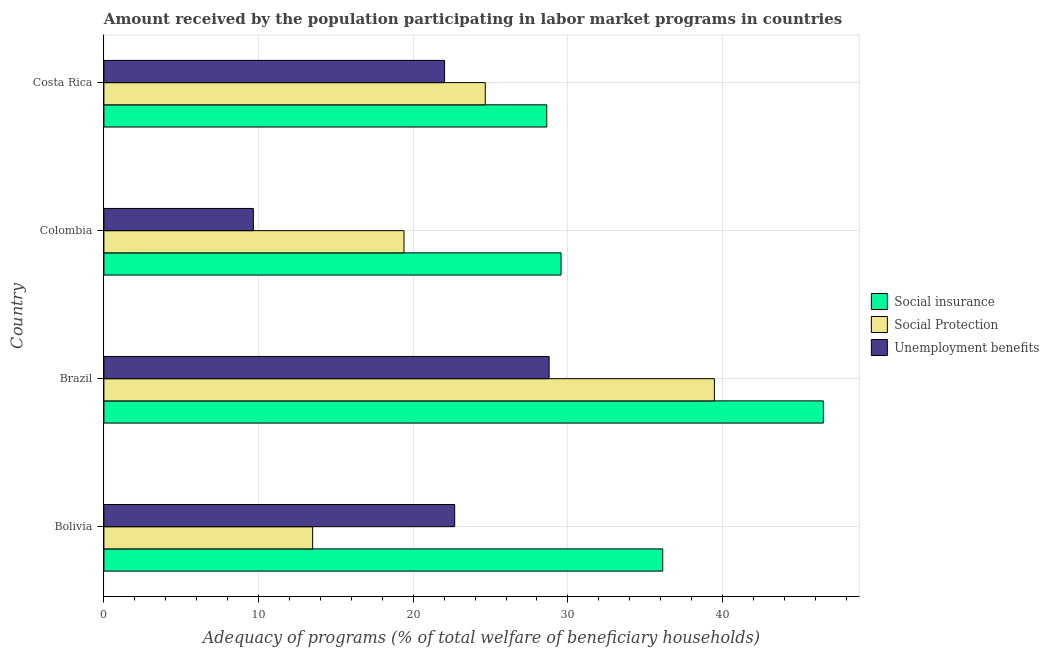Are the number of bars on each tick of the Y-axis equal?
Ensure brevity in your answer.  Yes. How many bars are there on the 1st tick from the top?
Make the answer very short. 3. How many bars are there on the 4th tick from the bottom?
Keep it short and to the point. 3. In how many cases, is the number of bars for a given country not equal to the number of legend labels?
Provide a succinct answer. 0. What is the amount received by the population participating in social insurance programs in Brazil?
Ensure brevity in your answer.  46.52. Across all countries, what is the maximum amount received by the population participating in social insurance programs?
Offer a terse response. 46.52. Across all countries, what is the minimum amount received by the population participating in unemployment benefits programs?
Provide a short and direct response. 9.66. What is the total amount received by the population participating in social protection programs in the graph?
Give a very brief answer. 97.03. What is the difference between the amount received by the population participating in social protection programs in Bolivia and that in Colombia?
Provide a succinct answer. -5.91. What is the difference between the amount received by the population participating in unemployment benefits programs in Colombia and the amount received by the population participating in social protection programs in Bolivia?
Keep it short and to the point. -3.83. What is the average amount received by the population participating in social protection programs per country?
Offer a very short reply. 24.26. What is the difference between the amount received by the population participating in unemployment benefits programs and amount received by the population participating in social protection programs in Colombia?
Offer a very short reply. -9.74. In how many countries, is the amount received by the population participating in social insurance programs greater than 8 %?
Your response must be concise. 4. What is the ratio of the amount received by the population participating in unemployment benefits programs in Brazil to that in Costa Rica?
Your response must be concise. 1.31. What is the difference between the highest and the second highest amount received by the population participating in social protection programs?
Provide a short and direct response. 14.81. What is the difference between the highest and the lowest amount received by the population participating in social protection programs?
Your answer should be compact. 25.98. Is the sum of the amount received by the population participating in social insurance programs in Bolivia and Costa Rica greater than the maximum amount received by the population participating in social protection programs across all countries?
Ensure brevity in your answer.  Yes. What does the 2nd bar from the top in Bolivia represents?
Make the answer very short. Social Protection. What does the 1st bar from the bottom in Bolivia represents?
Make the answer very short. Social insurance. Is it the case that in every country, the sum of the amount received by the population participating in social insurance programs and amount received by the population participating in social protection programs is greater than the amount received by the population participating in unemployment benefits programs?
Keep it short and to the point. Yes. How many bars are there?
Your answer should be compact. 12. How many countries are there in the graph?
Provide a short and direct response. 4. Are the values on the major ticks of X-axis written in scientific E-notation?
Your answer should be very brief. No. Does the graph contain any zero values?
Your response must be concise. No. Does the graph contain grids?
Provide a succinct answer. Yes. Where does the legend appear in the graph?
Provide a succinct answer. Center right. How many legend labels are there?
Offer a very short reply. 3. What is the title of the graph?
Your response must be concise. Amount received by the population participating in labor market programs in countries. Does "Ores and metals" appear as one of the legend labels in the graph?
Your answer should be very brief. No. What is the label or title of the X-axis?
Ensure brevity in your answer.  Adequacy of programs (% of total welfare of beneficiary households). What is the Adequacy of programs (% of total welfare of beneficiary households) in Social insurance in Bolivia?
Your answer should be compact. 36.13. What is the Adequacy of programs (% of total welfare of beneficiary households) of Social Protection in Bolivia?
Make the answer very short. 13.5. What is the Adequacy of programs (% of total welfare of beneficiary households) of Unemployment benefits in Bolivia?
Keep it short and to the point. 22.68. What is the Adequacy of programs (% of total welfare of beneficiary households) in Social insurance in Brazil?
Your answer should be compact. 46.52. What is the Adequacy of programs (% of total welfare of beneficiary households) in Social Protection in Brazil?
Offer a terse response. 39.47. What is the Adequacy of programs (% of total welfare of beneficiary households) in Unemployment benefits in Brazil?
Your answer should be very brief. 28.79. What is the Adequacy of programs (% of total welfare of beneficiary households) in Social insurance in Colombia?
Provide a short and direct response. 29.56. What is the Adequacy of programs (% of total welfare of beneficiary households) of Social Protection in Colombia?
Your response must be concise. 19.4. What is the Adequacy of programs (% of total welfare of beneficiary households) of Unemployment benefits in Colombia?
Your answer should be very brief. 9.66. What is the Adequacy of programs (% of total welfare of beneficiary households) of Social insurance in Costa Rica?
Offer a very short reply. 28.64. What is the Adequacy of programs (% of total welfare of beneficiary households) of Social Protection in Costa Rica?
Offer a very short reply. 24.66. What is the Adequacy of programs (% of total welfare of beneficiary households) in Unemployment benefits in Costa Rica?
Your answer should be compact. 22.03. Across all countries, what is the maximum Adequacy of programs (% of total welfare of beneficiary households) in Social insurance?
Keep it short and to the point. 46.52. Across all countries, what is the maximum Adequacy of programs (% of total welfare of beneficiary households) of Social Protection?
Your answer should be very brief. 39.47. Across all countries, what is the maximum Adequacy of programs (% of total welfare of beneficiary households) of Unemployment benefits?
Ensure brevity in your answer.  28.79. Across all countries, what is the minimum Adequacy of programs (% of total welfare of beneficiary households) of Social insurance?
Your answer should be compact. 28.64. Across all countries, what is the minimum Adequacy of programs (% of total welfare of beneficiary households) of Social Protection?
Your answer should be very brief. 13.5. Across all countries, what is the minimum Adequacy of programs (% of total welfare of beneficiary households) in Unemployment benefits?
Provide a short and direct response. 9.66. What is the total Adequacy of programs (% of total welfare of beneficiary households) of Social insurance in the graph?
Offer a very short reply. 140.85. What is the total Adequacy of programs (% of total welfare of beneficiary households) in Social Protection in the graph?
Provide a succinct answer. 97.03. What is the total Adequacy of programs (% of total welfare of beneficiary households) in Unemployment benefits in the graph?
Provide a succinct answer. 83.16. What is the difference between the Adequacy of programs (% of total welfare of beneficiary households) in Social insurance in Bolivia and that in Brazil?
Ensure brevity in your answer.  -10.39. What is the difference between the Adequacy of programs (% of total welfare of beneficiary households) in Social Protection in Bolivia and that in Brazil?
Offer a very short reply. -25.98. What is the difference between the Adequacy of programs (% of total welfare of beneficiary households) of Unemployment benefits in Bolivia and that in Brazil?
Offer a very short reply. -6.11. What is the difference between the Adequacy of programs (% of total welfare of beneficiary households) of Social insurance in Bolivia and that in Colombia?
Offer a terse response. 6.57. What is the difference between the Adequacy of programs (% of total welfare of beneficiary households) in Social Protection in Bolivia and that in Colombia?
Provide a succinct answer. -5.9. What is the difference between the Adequacy of programs (% of total welfare of beneficiary households) in Unemployment benefits in Bolivia and that in Colombia?
Give a very brief answer. 13.02. What is the difference between the Adequacy of programs (% of total welfare of beneficiary households) in Social insurance in Bolivia and that in Costa Rica?
Make the answer very short. 7.5. What is the difference between the Adequacy of programs (% of total welfare of beneficiary households) of Social Protection in Bolivia and that in Costa Rica?
Keep it short and to the point. -11.16. What is the difference between the Adequacy of programs (% of total welfare of beneficiary households) in Unemployment benefits in Bolivia and that in Costa Rica?
Offer a very short reply. 0.65. What is the difference between the Adequacy of programs (% of total welfare of beneficiary households) of Social insurance in Brazil and that in Colombia?
Make the answer very short. 16.96. What is the difference between the Adequacy of programs (% of total welfare of beneficiary households) of Social Protection in Brazil and that in Colombia?
Provide a succinct answer. 20.07. What is the difference between the Adequacy of programs (% of total welfare of beneficiary households) of Unemployment benefits in Brazil and that in Colombia?
Provide a succinct answer. 19.12. What is the difference between the Adequacy of programs (% of total welfare of beneficiary households) in Social insurance in Brazil and that in Costa Rica?
Offer a terse response. 17.89. What is the difference between the Adequacy of programs (% of total welfare of beneficiary households) of Social Protection in Brazil and that in Costa Rica?
Offer a terse response. 14.81. What is the difference between the Adequacy of programs (% of total welfare of beneficiary households) of Unemployment benefits in Brazil and that in Costa Rica?
Provide a succinct answer. 6.76. What is the difference between the Adequacy of programs (% of total welfare of beneficiary households) of Social Protection in Colombia and that in Costa Rica?
Ensure brevity in your answer.  -5.26. What is the difference between the Adequacy of programs (% of total welfare of beneficiary households) of Unemployment benefits in Colombia and that in Costa Rica?
Your answer should be compact. -12.37. What is the difference between the Adequacy of programs (% of total welfare of beneficiary households) in Social insurance in Bolivia and the Adequacy of programs (% of total welfare of beneficiary households) in Social Protection in Brazil?
Make the answer very short. -3.34. What is the difference between the Adequacy of programs (% of total welfare of beneficiary households) in Social insurance in Bolivia and the Adequacy of programs (% of total welfare of beneficiary households) in Unemployment benefits in Brazil?
Your response must be concise. 7.35. What is the difference between the Adequacy of programs (% of total welfare of beneficiary households) of Social Protection in Bolivia and the Adequacy of programs (% of total welfare of beneficiary households) of Unemployment benefits in Brazil?
Provide a succinct answer. -15.29. What is the difference between the Adequacy of programs (% of total welfare of beneficiary households) in Social insurance in Bolivia and the Adequacy of programs (% of total welfare of beneficiary households) in Social Protection in Colombia?
Give a very brief answer. 16.73. What is the difference between the Adequacy of programs (% of total welfare of beneficiary households) in Social insurance in Bolivia and the Adequacy of programs (% of total welfare of beneficiary households) in Unemployment benefits in Colombia?
Offer a terse response. 26.47. What is the difference between the Adequacy of programs (% of total welfare of beneficiary households) of Social Protection in Bolivia and the Adequacy of programs (% of total welfare of beneficiary households) of Unemployment benefits in Colombia?
Provide a succinct answer. 3.83. What is the difference between the Adequacy of programs (% of total welfare of beneficiary households) of Social insurance in Bolivia and the Adequacy of programs (% of total welfare of beneficiary households) of Social Protection in Costa Rica?
Provide a short and direct response. 11.47. What is the difference between the Adequacy of programs (% of total welfare of beneficiary households) in Social insurance in Bolivia and the Adequacy of programs (% of total welfare of beneficiary households) in Unemployment benefits in Costa Rica?
Offer a very short reply. 14.1. What is the difference between the Adequacy of programs (% of total welfare of beneficiary households) in Social Protection in Bolivia and the Adequacy of programs (% of total welfare of beneficiary households) in Unemployment benefits in Costa Rica?
Your answer should be compact. -8.53. What is the difference between the Adequacy of programs (% of total welfare of beneficiary households) in Social insurance in Brazil and the Adequacy of programs (% of total welfare of beneficiary households) in Social Protection in Colombia?
Offer a very short reply. 27.12. What is the difference between the Adequacy of programs (% of total welfare of beneficiary households) of Social insurance in Brazil and the Adequacy of programs (% of total welfare of beneficiary households) of Unemployment benefits in Colombia?
Your response must be concise. 36.86. What is the difference between the Adequacy of programs (% of total welfare of beneficiary households) of Social Protection in Brazil and the Adequacy of programs (% of total welfare of beneficiary households) of Unemployment benefits in Colombia?
Offer a very short reply. 29.81. What is the difference between the Adequacy of programs (% of total welfare of beneficiary households) of Social insurance in Brazil and the Adequacy of programs (% of total welfare of beneficiary households) of Social Protection in Costa Rica?
Provide a succinct answer. 21.86. What is the difference between the Adequacy of programs (% of total welfare of beneficiary households) in Social insurance in Brazil and the Adequacy of programs (% of total welfare of beneficiary households) in Unemployment benefits in Costa Rica?
Provide a short and direct response. 24.49. What is the difference between the Adequacy of programs (% of total welfare of beneficiary households) of Social Protection in Brazil and the Adequacy of programs (% of total welfare of beneficiary households) of Unemployment benefits in Costa Rica?
Your answer should be compact. 17.44. What is the difference between the Adequacy of programs (% of total welfare of beneficiary households) in Social insurance in Colombia and the Adequacy of programs (% of total welfare of beneficiary households) in Social Protection in Costa Rica?
Make the answer very short. 4.9. What is the difference between the Adequacy of programs (% of total welfare of beneficiary households) of Social insurance in Colombia and the Adequacy of programs (% of total welfare of beneficiary households) of Unemployment benefits in Costa Rica?
Your answer should be compact. 7.53. What is the difference between the Adequacy of programs (% of total welfare of beneficiary households) in Social Protection in Colombia and the Adequacy of programs (% of total welfare of beneficiary households) in Unemployment benefits in Costa Rica?
Provide a succinct answer. -2.63. What is the average Adequacy of programs (% of total welfare of beneficiary households) in Social insurance per country?
Provide a short and direct response. 35.21. What is the average Adequacy of programs (% of total welfare of beneficiary households) of Social Protection per country?
Your response must be concise. 24.26. What is the average Adequacy of programs (% of total welfare of beneficiary households) in Unemployment benefits per country?
Your answer should be very brief. 20.79. What is the difference between the Adequacy of programs (% of total welfare of beneficiary households) in Social insurance and Adequacy of programs (% of total welfare of beneficiary households) in Social Protection in Bolivia?
Ensure brevity in your answer.  22.64. What is the difference between the Adequacy of programs (% of total welfare of beneficiary households) of Social insurance and Adequacy of programs (% of total welfare of beneficiary households) of Unemployment benefits in Bolivia?
Provide a short and direct response. 13.45. What is the difference between the Adequacy of programs (% of total welfare of beneficiary households) in Social Protection and Adequacy of programs (% of total welfare of beneficiary households) in Unemployment benefits in Bolivia?
Provide a succinct answer. -9.19. What is the difference between the Adequacy of programs (% of total welfare of beneficiary households) of Social insurance and Adequacy of programs (% of total welfare of beneficiary households) of Social Protection in Brazil?
Provide a succinct answer. 7.05. What is the difference between the Adequacy of programs (% of total welfare of beneficiary households) in Social insurance and Adequacy of programs (% of total welfare of beneficiary households) in Unemployment benefits in Brazil?
Keep it short and to the point. 17.73. What is the difference between the Adequacy of programs (% of total welfare of beneficiary households) in Social Protection and Adequacy of programs (% of total welfare of beneficiary households) in Unemployment benefits in Brazil?
Provide a short and direct response. 10.69. What is the difference between the Adequacy of programs (% of total welfare of beneficiary households) in Social insurance and Adequacy of programs (% of total welfare of beneficiary households) in Social Protection in Colombia?
Provide a succinct answer. 10.16. What is the difference between the Adequacy of programs (% of total welfare of beneficiary households) in Social insurance and Adequacy of programs (% of total welfare of beneficiary households) in Unemployment benefits in Colombia?
Keep it short and to the point. 19.9. What is the difference between the Adequacy of programs (% of total welfare of beneficiary households) of Social Protection and Adequacy of programs (% of total welfare of beneficiary households) of Unemployment benefits in Colombia?
Give a very brief answer. 9.74. What is the difference between the Adequacy of programs (% of total welfare of beneficiary households) of Social insurance and Adequacy of programs (% of total welfare of beneficiary households) of Social Protection in Costa Rica?
Offer a terse response. 3.98. What is the difference between the Adequacy of programs (% of total welfare of beneficiary households) in Social insurance and Adequacy of programs (% of total welfare of beneficiary households) in Unemployment benefits in Costa Rica?
Your answer should be very brief. 6.61. What is the difference between the Adequacy of programs (% of total welfare of beneficiary households) in Social Protection and Adequacy of programs (% of total welfare of beneficiary households) in Unemployment benefits in Costa Rica?
Offer a terse response. 2.63. What is the ratio of the Adequacy of programs (% of total welfare of beneficiary households) of Social insurance in Bolivia to that in Brazil?
Offer a terse response. 0.78. What is the ratio of the Adequacy of programs (% of total welfare of beneficiary households) of Social Protection in Bolivia to that in Brazil?
Your answer should be very brief. 0.34. What is the ratio of the Adequacy of programs (% of total welfare of beneficiary households) of Unemployment benefits in Bolivia to that in Brazil?
Give a very brief answer. 0.79. What is the ratio of the Adequacy of programs (% of total welfare of beneficiary households) in Social insurance in Bolivia to that in Colombia?
Your answer should be compact. 1.22. What is the ratio of the Adequacy of programs (% of total welfare of beneficiary households) of Social Protection in Bolivia to that in Colombia?
Offer a very short reply. 0.7. What is the ratio of the Adequacy of programs (% of total welfare of beneficiary households) of Unemployment benefits in Bolivia to that in Colombia?
Offer a terse response. 2.35. What is the ratio of the Adequacy of programs (% of total welfare of beneficiary households) of Social insurance in Bolivia to that in Costa Rica?
Provide a short and direct response. 1.26. What is the ratio of the Adequacy of programs (% of total welfare of beneficiary households) of Social Protection in Bolivia to that in Costa Rica?
Your response must be concise. 0.55. What is the ratio of the Adequacy of programs (% of total welfare of beneficiary households) of Unemployment benefits in Bolivia to that in Costa Rica?
Your answer should be very brief. 1.03. What is the ratio of the Adequacy of programs (% of total welfare of beneficiary households) in Social insurance in Brazil to that in Colombia?
Provide a short and direct response. 1.57. What is the ratio of the Adequacy of programs (% of total welfare of beneficiary households) in Social Protection in Brazil to that in Colombia?
Keep it short and to the point. 2.03. What is the ratio of the Adequacy of programs (% of total welfare of beneficiary households) of Unemployment benefits in Brazil to that in Colombia?
Your response must be concise. 2.98. What is the ratio of the Adequacy of programs (% of total welfare of beneficiary households) in Social insurance in Brazil to that in Costa Rica?
Provide a short and direct response. 1.62. What is the ratio of the Adequacy of programs (% of total welfare of beneficiary households) of Social Protection in Brazil to that in Costa Rica?
Your response must be concise. 1.6. What is the ratio of the Adequacy of programs (% of total welfare of beneficiary households) of Unemployment benefits in Brazil to that in Costa Rica?
Provide a succinct answer. 1.31. What is the ratio of the Adequacy of programs (% of total welfare of beneficiary households) in Social insurance in Colombia to that in Costa Rica?
Your answer should be compact. 1.03. What is the ratio of the Adequacy of programs (% of total welfare of beneficiary households) of Social Protection in Colombia to that in Costa Rica?
Offer a terse response. 0.79. What is the ratio of the Adequacy of programs (% of total welfare of beneficiary households) of Unemployment benefits in Colombia to that in Costa Rica?
Offer a very short reply. 0.44. What is the difference between the highest and the second highest Adequacy of programs (% of total welfare of beneficiary households) in Social insurance?
Provide a succinct answer. 10.39. What is the difference between the highest and the second highest Adequacy of programs (% of total welfare of beneficiary households) of Social Protection?
Your answer should be compact. 14.81. What is the difference between the highest and the second highest Adequacy of programs (% of total welfare of beneficiary households) in Unemployment benefits?
Your answer should be compact. 6.11. What is the difference between the highest and the lowest Adequacy of programs (% of total welfare of beneficiary households) of Social insurance?
Ensure brevity in your answer.  17.89. What is the difference between the highest and the lowest Adequacy of programs (% of total welfare of beneficiary households) in Social Protection?
Make the answer very short. 25.98. What is the difference between the highest and the lowest Adequacy of programs (% of total welfare of beneficiary households) in Unemployment benefits?
Provide a short and direct response. 19.12. 